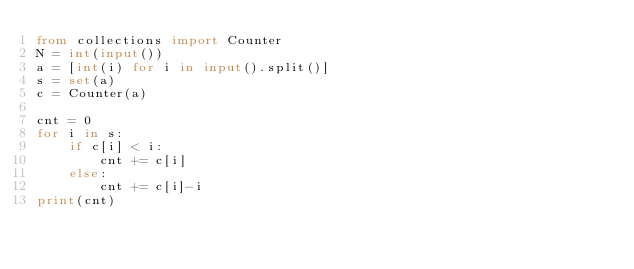<code> <loc_0><loc_0><loc_500><loc_500><_Python_>from collections import Counter
N = int(input())
a = [int(i) for i in input().split()]
s = set(a)
c = Counter(a)

cnt = 0
for i in s:
    if c[i] < i:
        cnt += c[i]
    else:
        cnt += c[i]-i
print(cnt)</code> 